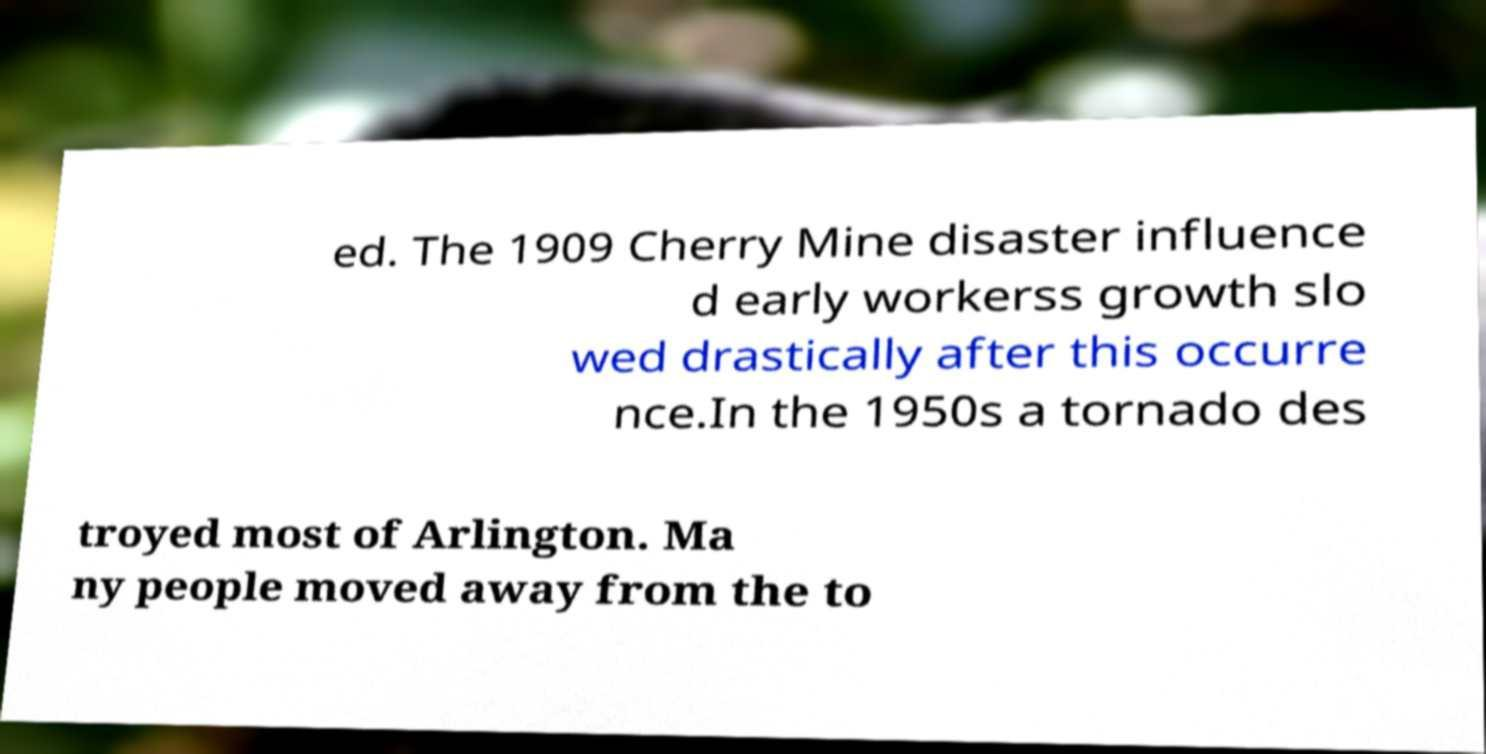Please identify and transcribe the text found in this image. ed. The 1909 Cherry Mine disaster influence d early workerss growth slo wed drastically after this occurre nce.In the 1950s a tornado des troyed most of Arlington. Ma ny people moved away from the to 